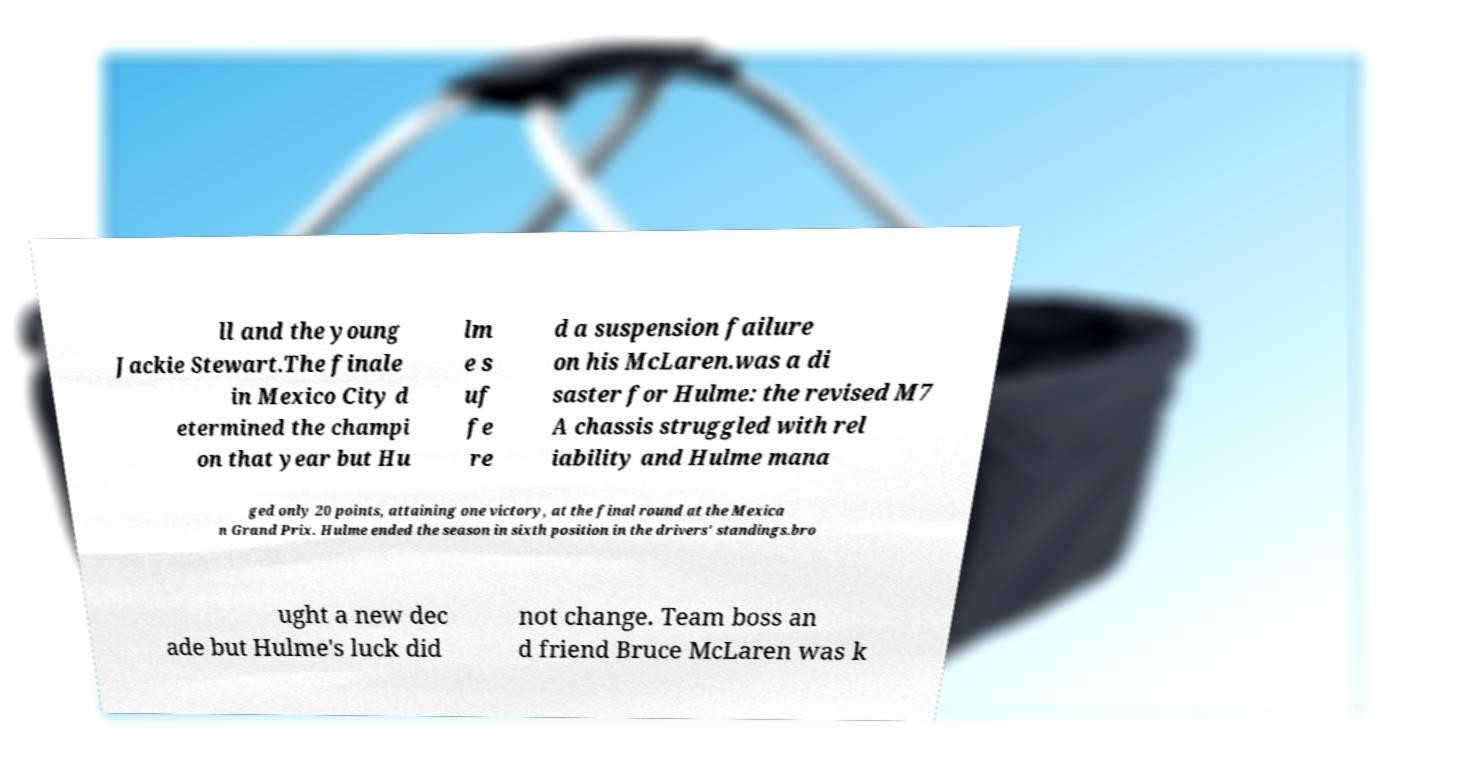Can you read and provide the text displayed in the image?This photo seems to have some interesting text. Can you extract and type it out for me? ll and the young Jackie Stewart.The finale in Mexico City d etermined the champi on that year but Hu lm e s uf fe re d a suspension failure on his McLaren.was a di saster for Hulme: the revised M7 A chassis struggled with rel iability and Hulme mana ged only 20 points, attaining one victory, at the final round at the Mexica n Grand Prix. Hulme ended the season in sixth position in the drivers' standings.bro ught a new dec ade but Hulme's luck did not change. Team boss an d friend Bruce McLaren was k 